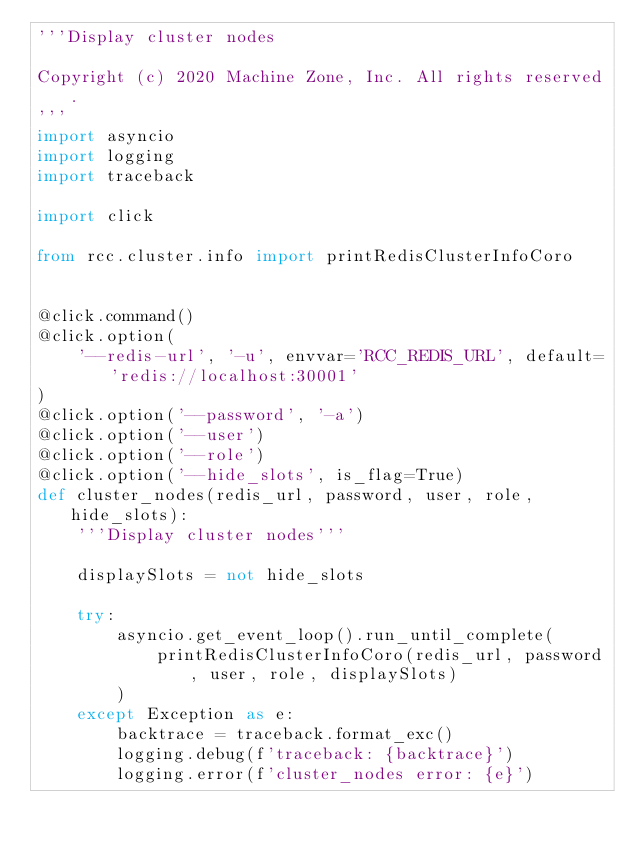<code> <loc_0><loc_0><loc_500><loc_500><_Python_>'''Display cluster nodes

Copyright (c) 2020 Machine Zone, Inc. All rights reserved.
'''
import asyncio
import logging
import traceback

import click

from rcc.cluster.info import printRedisClusterInfoCoro


@click.command()
@click.option(
    '--redis-url', '-u', envvar='RCC_REDIS_URL', default='redis://localhost:30001'
)
@click.option('--password', '-a')
@click.option('--user')
@click.option('--role')
@click.option('--hide_slots', is_flag=True)
def cluster_nodes(redis_url, password, user, role, hide_slots):
    '''Display cluster nodes'''

    displaySlots = not hide_slots

    try:
        asyncio.get_event_loop().run_until_complete(
            printRedisClusterInfoCoro(redis_url, password, user, role, displaySlots)
        )
    except Exception as e:
        backtrace = traceback.format_exc()
        logging.debug(f'traceback: {backtrace}')
        logging.error(f'cluster_nodes error: {e}')
</code> 